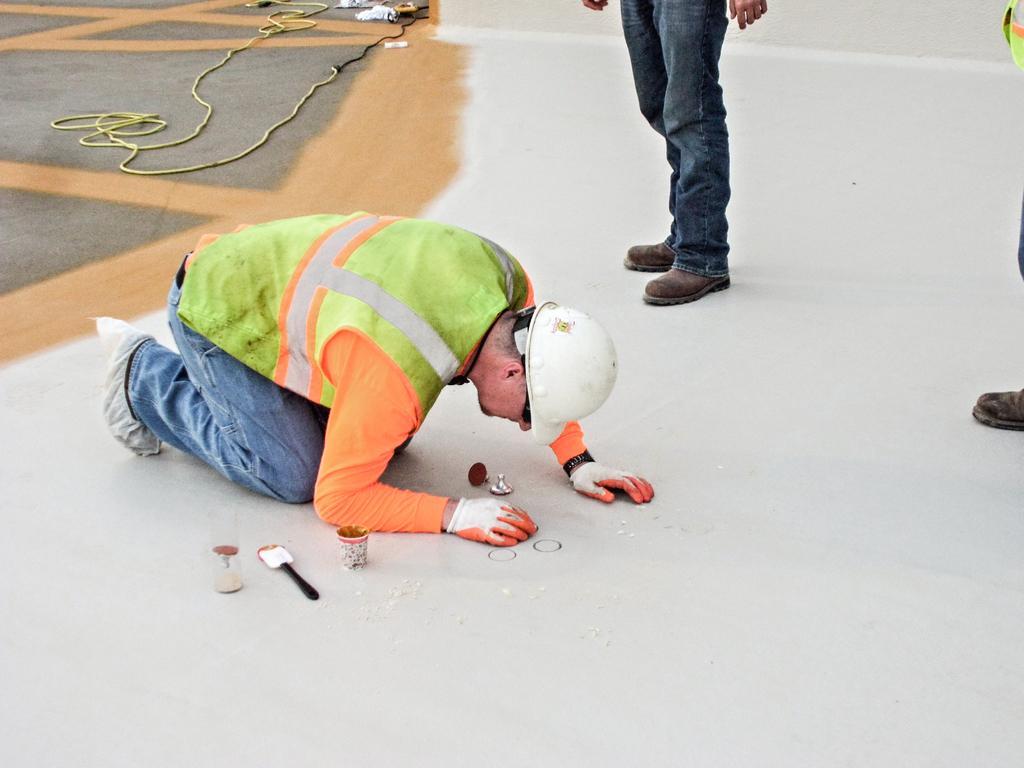Please provide a concise description of this image. Here in this picture, in the middle we can see a person present on the floor and we can see he is wearing apron, goggles, helmet, gloves on him and he is designing the floor and beside him we can see some things present and on the right side we can see two other people also standing on the floor and behind him we can see some floor that is painted and we can also see some wires present. 